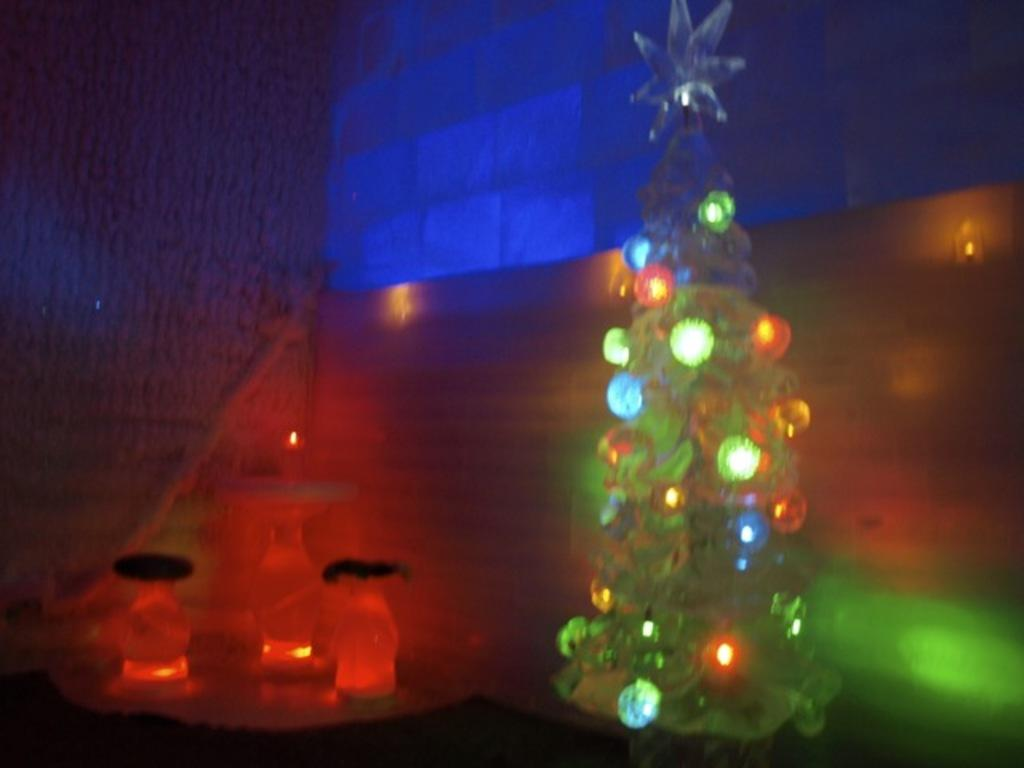What type of decorative items are present in the image? There are decorative things with lights in the image. What is a feature of the walls in the image? There are walls with lights in the image. How many spiders can be seen crawling on the decorative items in the image? There are no spiders present in the image. What type of knowledge can be gained from observing the decorative items in the image? The image does not convey any specific knowledge or information; it simply shows decorative items with lights. 